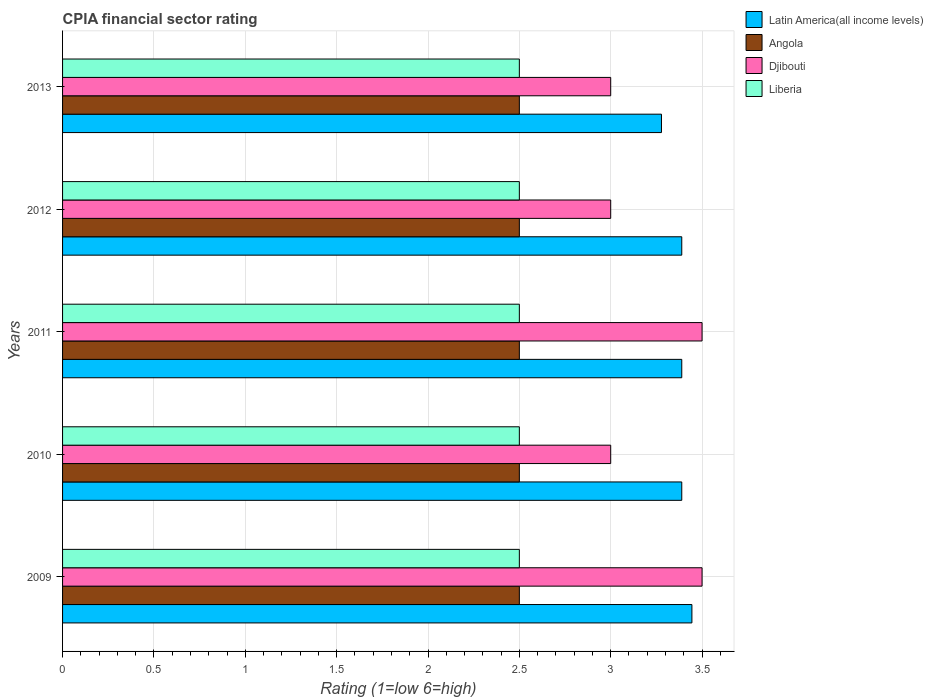How many different coloured bars are there?
Your answer should be compact. 4. Are the number of bars per tick equal to the number of legend labels?
Your response must be concise. Yes. How many bars are there on the 3rd tick from the bottom?
Offer a terse response. 4. What is the label of the 5th group of bars from the top?
Your response must be concise. 2009. Across all years, what is the maximum CPIA rating in Djibouti?
Your answer should be very brief. 3.5. What is the total CPIA rating in Djibouti in the graph?
Your response must be concise. 16. What is the difference between the CPIA rating in Latin America(all income levels) in 2010 and that in 2013?
Your response must be concise. 0.11. What is the difference between the CPIA rating in Angola in 2010 and the CPIA rating in Latin America(all income levels) in 2013?
Make the answer very short. -0.78. What is the average CPIA rating in Latin America(all income levels) per year?
Make the answer very short. 3.38. In the year 2009, what is the difference between the CPIA rating in Latin America(all income levels) and CPIA rating in Liberia?
Your answer should be compact. 0.94. What is the ratio of the CPIA rating in Djibouti in 2009 to that in 2010?
Provide a succinct answer. 1.17. Is the difference between the CPIA rating in Latin America(all income levels) in 2010 and 2011 greater than the difference between the CPIA rating in Liberia in 2010 and 2011?
Make the answer very short. No. What is the difference between the highest and the second highest CPIA rating in Djibouti?
Provide a short and direct response. 0. What is the difference between the highest and the lowest CPIA rating in Liberia?
Offer a very short reply. 0. In how many years, is the CPIA rating in Liberia greater than the average CPIA rating in Liberia taken over all years?
Your answer should be very brief. 0. What does the 1st bar from the top in 2011 represents?
Your answer should be compact. Liberia. What does the 1st bar from the bottom in 2009 represents?
Your response must be concise. Latin America(all income levels). Is it the case that in every year, the sum of the CPIA rating in Angola and CPIA rating in Djibouti is greater than the CPIA rating in Liberia?
Provide a short and direct response. Yes. How many bars are there?
Your response must be concise. 20. What is the difference between two consecutive major ticks on the X-axis?
Provide a short and direct response. 0.5. Are the values on the major ticks of X-axis written in scientific E-notation?
Offer a very short reply. No. Does the graph contain any zero values?
Make the answer very short. No. Does the graph contain grids?
Offer a very short reply. Yes. Where does the legend appear in the graph?
Offer a very short reply. Top right. How many legend labels are there?
Ensure brevity in your answer.  4. How are the legend labels stacked?
Make the answer very short. Vertical. What is the title of the graph?
Offer a terse response. CPIA financial sector rating. Does "Guinea-Bissau" appear as one of the legend labels in the graph?
Provide a short and direct response. No. What is the Rating (1=low 6=high) of Latin America(all income levels) in 2009?
Your answer should be compact. 3.44. What is the Rating (1=low 6=high) in Angola in 2009?
Your answer should be compact. 2.5. What is the Rating (1=low 6=high) of Latin America(all income levels) in 2010?
Your answer should be compact. 3.39. What is the Rating (1=low 6=high) of Angola in 2010?
Ensure brevity in your answer.  2.5. What is the Rating (1=low 6=high) in Djibouti in 2010?
Offer a very short reply. 3. What is the Rating (1=low 6=high) in Latin America(all income levels) in 2011?
Your answer should be compact. 3.39. What is the Rating (1=low 6=high) of Angola in 2011?
Make the answer very short. 2.5. What is the Rating (1=low 6=high) of Liberia in 2011?
Provide a succinct answer. 2.5. What is the Rating (1=low 6=high) of Latin America(all income levels) in 2012?
Offer a very short reply. 3.39. What is the Rating (1=low 6=high) in Djibouti in 2012?
Give a very brief answer. 3. What is the Rating (1=low 6=high) in Liberia in 2012?
Your answer should be compact. 2.5. What is the Rating (1=low 6=high) in Latin America(all income levels) in 2013?
Provide a short and direct response. 3.28. What is the Rating (1=low 6=high) of Angola in 2013?
Offer a very short reply. 2.5. Across all years, what is the maximum Rating (1=low 6=high) of Latin America(all income levels)?
Provide a succinct answer. 3.44. Across all years, what is the maximum Rating (1=low 6=high) of Djibouti?
Your answer should be compact. 3.5. Across all years, what is the minimum Rating (1=low 6=high) of Latin America(all income levels)?
Offer a terse response. 3.28. What is the total Rating (1=low 6=high) of Latin America(all income levels) in the graph?
Provide a short and direct response. 16.89. What is the difference between the Rating (1=low 6=high) in Latin America(all income levels) in 2009 and that in 2010?
Keep it short and to the point. 0.06. What is the difference between the Rating (1=low 6=high) of Angola in 2009 and that in 2010?
Keep it short and to the point. 0. What is the difference between the Rating (1=low 6=high) of Liberia in 2009 and that in 2010?
Ensure brevity in your answer.  0. What is the difference between the Rating (1=low 6=high) in Latin America(all income levels) in 2009 and that in 2011?
Give a very brief answer. 0.06. What is the difference between the Rating (1=low 6=high) of Angola in 2009 and that in 2011?
Your response must be concise. 0. What is the difference between the Rating (1=low 6=high) in Latin America(all income levels) in 2009 and that in 2012?
Make the answer very short. 0.06. What is the difference between the Rating (1=low 6=high) in Angola in 2009 and that in 2012?
Give a very brief answer. 0. What is the difference between the Rating (1=low 6=high) in Latin America(all income levels) in 2009 and that in 2013?
Provide a short and direct response. 0.17. What is the difference between the Rating (1=low 6=high) of Angola in 2009 and that in 2013?
Your answer should be compact. 0. What is the difference between the Rating (1=low 6=high) in Latin America(all income levels) in 2010 and that in 2011?
Keep it short and to the point. 0. What is the difference between the Rating (1=low 6=high) in Djibouti in 2010 and that in 2011?
Provide a short and direct response. -0.5. What is the difference between the Rating (1=low 6=high) in Latin America(all income levels) in 2010 and that in 2012?
Your answer should be compact. 0. What is the difference between the Rating (1=low 6=high) of Angola in 2010 and that in 2012?
Provide a succinct answer. 0. What is the difference between the Rating (1=low 6=high) of Djibouti in 2010 and that in 2013?
Offer a terse response. 0. What is the difference between the Rating (1=low 6=high) of Latin America(all income levels) in 2011 and that in 2012?
Your response must be concise. 0. What is the difference between the Rating (1=low 6=high) of Djibouti in 2011 and that in 2012?
Ensure brevity in your answer.  0.5. What is the difference between the Rating (1=low 6=high) of Latin America(all income levels) in 2011 and that in 2013?
Provide a short and direct response. 0.11. What is the difference between the Rating (1=low 6=high) of Angola in 2011 and that in 2013?
Your answer should be compact. 0. What is the difference between the Rating (1=low 6=high) in Latin America(all income levels) in 2012 and that in 2013?
Provide a succinct answer. 0.11. What is the difference between the Rating (1=low 6=high) of Angola in 2012 and that in 2013?
Give a very brief answer. 0. What is the difference between the Rating (1=low 6=high) in Latin America(all income levels) in 2009 and the Rating (1=low 6=high) in Djibouti in 2010?
Keep it short and to the point. 0.44. What is the difference between the Rating (1=low 6=high) of Djibouti in 2009 and the Rating (1=low 6=high) of Liberia in 2010?
Keep it short and to the point. 1. What is the difference between the Rating (1=low 6=high) of Latin America(all income levels) in 2009 and the Rating (1=low 6=high) of Angola in 2011?
Give a very brief answer. 0.94. What is the difference between the Rating (1=low 6=high) of Latin America(all income levels) in 2009 and the Rating (1=low 6=high) of Djibouti in 2011?
Your answer should be compact. -0.06. What is the difference between the Rating (1=low 6=high) in Latin America(all income levels) in 2009 and the Rating (1=low 6=high) in Liberia in 2011?
Keep it short and to the point. 0.94. What is the difference between the Rating (1=low 6=high) of Latin America(all income levels) in 2009 and the Rating (1=low 6=high) of Angola in 2012?
Make the answer very short. 0.94. What is the difference between the Rating (1=low 6=high) of Latin America(all income levels) in 2009 and the Rating (1=low 6=high) of Djibouti in 2012?
Offer a terse response. 0.44. What is the difference between the Rating (1=low 6=high) in Latin America(all income levels) in 2009 and the Rating (1=low 6=high) in Liberia in 2012?
Offer a terse response. 0.94. What is the difference between the Rating (1=low 6=high) in Angola in 2009 and the Rating (1=low 6=high) in Djibouti in 2012?
Offer a very short reply. -0.5. What is the difference between the Rating (1=low 6=high) in Angola in 2009 and the Rating (1=low 6=high) in Liberia in 2012?
Offer a terse response. 0. What is the difference between the Rating (1=low 6=high) in Latin America(all income levels) in 2009 and the Rating (1=low 6=high) in Angola in 2013?
Make the answer very short. 0.94. What is the difference between the Rating (1=low 6=high) of Latin America(all income levels) in 2009 and the Rating (1=low 6=high) of Djibouti in 2013?
Offer a terse response. 0.44. What is the difference between the Rating (1=low 6=high) of Djibouti in 2009 and the Rating (1=low 6=high) of Liberia in 2013?
Keep it short and to the point. 1. What is the difference between the Rating (1=low 6=high) in Latin America(all income levels) in 2010 and the Rating (1=low 6=high) in Djibouti in 2011?
Your response must be concise. -0.11. What is the difference between the Rating (1=low 6=high) in Djibouti in 2010 and the Rating (1=low 6=high) in Liberia in 2011?
Provide a short and direct response. 0.5. What is the difference between the Rating (1=low 6=high) of Latin America(all income levels) in 2010 and the Rating (1=low 6=high) of Djibouti in 2012?
Make the answer very short. 0.39. What is the difference between the Rating (1=low 6=high) in Latin America(all income levels) in 2010 and the Rating (1=low 6=high) in Liberia in 2012?
Offer a terse response. 0.89. What is the difference between the Rating (1=low 6=high) in Angola in 2010 and the Rating (1=low 6=high) in Liberia in 2012?
Offer a very short reply. 0. What is the difference between the Rating (1=low 6=high) of Latin America(all income levels) in 2010 and the Rating (1=low 6=high) of Djibouti in 2013?
Keep it short and to the point. 0.39. What is the difference between the Rating (1=low 6=high) of Angola in 2010 and the Rating (1=low 6=high) of Liberia in 2013?
Offer a very short reply. 0. What is the difference between the Rating (1=low 6=high) of Djibouti in 2010 and the Rating (1=low 6=high) of Liberia in 2013?
Make the answer very short. 0.5. What is the difference between the Rating (1=low 6=high) of Latin America(all income levels) in 2011 and the Rating (1=low 6=high) of Djibouti in 2012?
Ensure brevity in your answer.  0.39. What is the difference between the Rating (1=low 6=high) of Latin America(all income levels) in 2011 and the Rating (1=low 6=high) of Liberia in 2012?
Your answer should be very brief. 0.89. What is the difference between the Rating (1=low 6=high) in Djibouti in 2011 and the Rating (1=low 6=high) in Liberia in 2012?
Make the answer very short. 1. What is the difference between the Rating (1=low 6=high) in Latin America(all income levels) in 2011 and the Rating (1=low 6=high) in Djibouti in 2013?
Your answer should be compact. 0.39. What is the difference between the Rating (1=low 6=high) in Djibouti in 2011 and the Rating (1=low 6=high) in Liberia in 2013?
Your answer should be compact. 1. What is the difference between the Rating (1=low 6=high) of Latin America(all income levels) in 2012 and the Rating (1=low 6=high) of Angola in 2013?
Keep it short and to the point. 0.89. What is the difference between the Rating (1=low 6=high) in Latin America(all income levels) in 2012 and the Rating (1=low 6=high) in Djibouti in 2013?
Offer a terse response. 0.39. What is the difference between the Rating (1=low 6=high) of Angola in 2012 and the Rating (1=low 6=high) of Djibouti in 2013?
Offer a terse response. -0.5. What is the average Rating (1=low 6=high) of Latin America(all income levels) per year?
Offer a very short reply. 3.38. What is the average Rating (1=low 6=high) of Angola per year?
Your answer should be very brief. 2.5. What is the average Rating (1=low 6=high) in Liberia per year?
Provide a succinct answer. 2.5. In the year 2009, what is the difference between the Rating (1=low 6=high) of Latin America(all income levels) and Rating (1=low 6=high) of Angola?
Offer a very short reply. 0.94. In the year 2009, what is the difference between the Rating (1=low 6=high) in Latin America(all income levels) and Rating (1=low 6=high) in Djibouti?
Your response must be concise. -0.06. In the year 2009, what is the difference between the Rating (1=low 6=high) in Angola and Rating (1=low 6=high) in Djibouti?
Offer a very short reply. -1. In the year 2009, what is the difference between the Rating (1=low 6=high) of Djibouti and Rating (1=low 6=high) of Liberia?
Your answer should be compact. 1. In the year 2010, what is the difference between the Rating (1=low 6=high) in Latin America(all income levels) and Rating (1=low 6=high) in Angola?
Your response must be concise. 0.89. In the year 2010, what is the difference between the Rating (1=low 6=high) in Latin America(all income levels) and Rating (1=low 6=high) in Djibouti?
Give a very brief answer. 0.39. In the year 2010, what is the difference between the Rating (1=low 6=high) in Latin America(all income levels) and Rating (1=low 6=high) in Liberia?
Keep it short and to the point. 0.89. In the year 2010, what is the difference between the Rating (1=low 6=high) of Angola and Rating (1=low 6=high) of Djibouti?
Your answer should be compact. -0.5. In the year 2010, what is the difference between the Rating (1=low 6=high) in Djibouti and Rating (1=low 6=high) in Liberia?
Make the answer very short. 0.5. In the year 2011, what is the difference between the Rating (1=low 6=high) of Latin America(all income levels) and Rating (1=low 6=high) of Djibouti?
Provide a succinct answer. -0.11. In the year 2011, what is the difference between the Rating (1=low 6=high) in Latin America(all income levels) and Rating (1=low 6=high) in Liberia?
Offer a very short reply. 0.89. In the year 2011, what is the difference between the Rating (1=low 6=high) in Angola and Rating (1=low 6=high) in Liberia?
Give a very brief answer. 0. In the year 2012, what is the difference between the Rating (1=low 6=high) of Latin America(all income levels) and Rating (1=low 6=high) of Djibouti?
Provide a succinct answer. 0.39. In the year 2012, what is the difference between the Rating (1=low 6=high) in Angola and Rating (1=low 6=high) in Liberia?
Keep it short and to the point. 0. In the year 2013, what is the difference between the Rating (1=low 6=high) in Latin America(all income levels) and Rating (1=low 6=high) in Djibouti?
Make the answer very short. 0.28. In the year 2013, what is the difference between the Rating (1=low 6=high) in Angola and Rating (1=low 6=high) in Djibouti?
Offer a terse response. -0.5. What is the ratio of the Rating (1=low 6=high) of Latin America(all income levels) in 2009 to that in 2010?
Keep it short and to the point. 1.02. What is the ratio of the Rating (1=low 6=high) of Angola in 2009 to that in 2010?
Offer a very short reply. 1. What is the ratio of the Rating (1=low 6=high) in Djibouti in 2009 to that in 2010?
Your response must be concise. 1.17. What is the ratio of the Rating (1=low 6=high) of Latin America(all income levels) in 2009 to that in 2011?
Give a very brief answer. 1.02. What is the ratio of the Rating (1=low 6=high) of Latin America(all income levels) in 2009 to that in 2012?
Keep it short and to the point. 1.02. What is the ratio of the Rating (1=low 6=high) in Angola in 2009 to that in 2012?
Your answer should be very brief. 1. What is the ratio of the Rating (1=low 6=high) of Djibouti in 2009 to that in 2012?
Keep it short and to the point. 1.17. What is the ratio of the Rating (1=low 6=high) in Latin America(all income levels) in 2009 to that in 2013?
Offer a very short reply. 1.05. What is the ratio of the Rating (1=low 6=high) of Angola in 2009 to that in 2013?
Your answer should be compact. 1. What is the ratio of the Rating (1=low 6=high) of Djibouti in 2009 to that in 2013?
Your response must be concise. 1.17. What is the ratio of the Rating (1=low 6=high) of Liberia in 2009 to that in 2013?
Offer a terse response. 1. What is the ratio of the Rating (1=low 6=high) in Latin America(all income levels) in 2010 to that in 2011?
Provide a short and direct response. 1. What is the ratio of the Rating (1=low 6=high) of Latin America(all income levels) in 2010 to that in 2012?
Your response must be concise. 1. What is the ratio of the Rating (1=low 6=high) of Angola in 2010 to that in 2012?
Make the answer very short. 1. What is the ratio of the Rating (1=low 6=high) in Liberia in 2010 to that in 2012?
Give a very brief answer. 1. What is the ratio of the Rating (1=low 6=high) of Latin America(all income levels) in 2010 to that in 2013?
Provide a short and direct response. 1.03. What is the ratio of the Rating (1=low 6=high) in Djibouti in 2010 to that in 2013?
Offer a very short reply. 1. What is the ratio of the Rating (1=low 6=high) of Liberia in 2010 to that in 2013?
Keep it short and to the point. 1. What is the ratio of the Rating (1=low 6=high) in Djibouti in 2011 to that in 2012?
Keep it short and to the point. 1.17. What is the ratio of the Rating (1=low 6=high) of Liberia in 2011 to that in 2012?
Ensure brevity in your answer.  1. What is the ratio of the Rating (1=low 6=high) in Latin America(all income levels) in 2011 to that in 2013?
Offer a very short reply. 1.03. What is the ratio of the Rating (1=low 6=high) of Angola in 2011 to that in 2013?
Provide a short and direct response. 1. What is the ratio of the Rating (1=low 6=high) in Djibouti in 2011 to that in 2013?
Ensure brevity in your answer.  1.17. What is the ratio of the Rating (1=low 6=high) in Liberia in 2011 to that in 2013?
Your response must be concise. 1. What is the ratio of the Rating (1=low 6=high) of Latin America(all income levels) in 2012 to that in 2013?
Your answer should be compact. 1.03. What is the ratio of the Rating (1=low 6=high) in Angola in 2012 to that in 2013?
Keep it short and to the point. 1. What is the ratio of the Rating (1=low 6=high) of Liberia in 2012 to that in 2013?
Provide a short and direct response. 1. What is the difference between the highest and the second highest Rating (1=low 6=high) in Latin America(all income levels)?
Provide a short and direct response. 0.06. What is the difference between the highest and the second highest Rating (1=low 6=high) in Djibouti?
Keep it short and to the point. 0. What is the difference between the highest and the lowest Rating (1=low 6=high) of Latin America(all income levels)?
Your answer should be very brief. 0.17. What is the difference between the highest and the lowest Rating (1=low 6=high) of Angola?
Give a very brief answer. 0. What is the difference between the highest and the lowest Rating (1=low 6=high) of Liberia?
Keep it short and to the point. 0. 